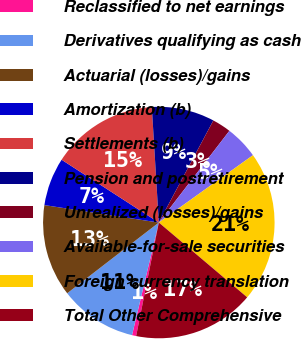Convert chart to OTSL. <chart><loc_0><loc_0><loc_500><loc_500><pie_chart><fcel>Reclassified to net earnings<fcel>Derivatives qualifying as cash<fcel>Actuarial (losses)/gains<fcel>Amortization (b)<fcel>Settlements (b)<fcel>Pension and postretirement<fcel>Unrealized (losses)/gains<fcel>Available-for-sale securities<fcel>Foreign currency translation<fcel>Total Other Comprehensive<nl><fcel>0.58%<fcel>10.82%<fcel>12.87%<fcel>6.72%<fcel>14.91%<fcel>8.77%<fcel>2.63%<fcel>4.68%<fcel>21.06%<fcel>16.96%<nl></chart> 